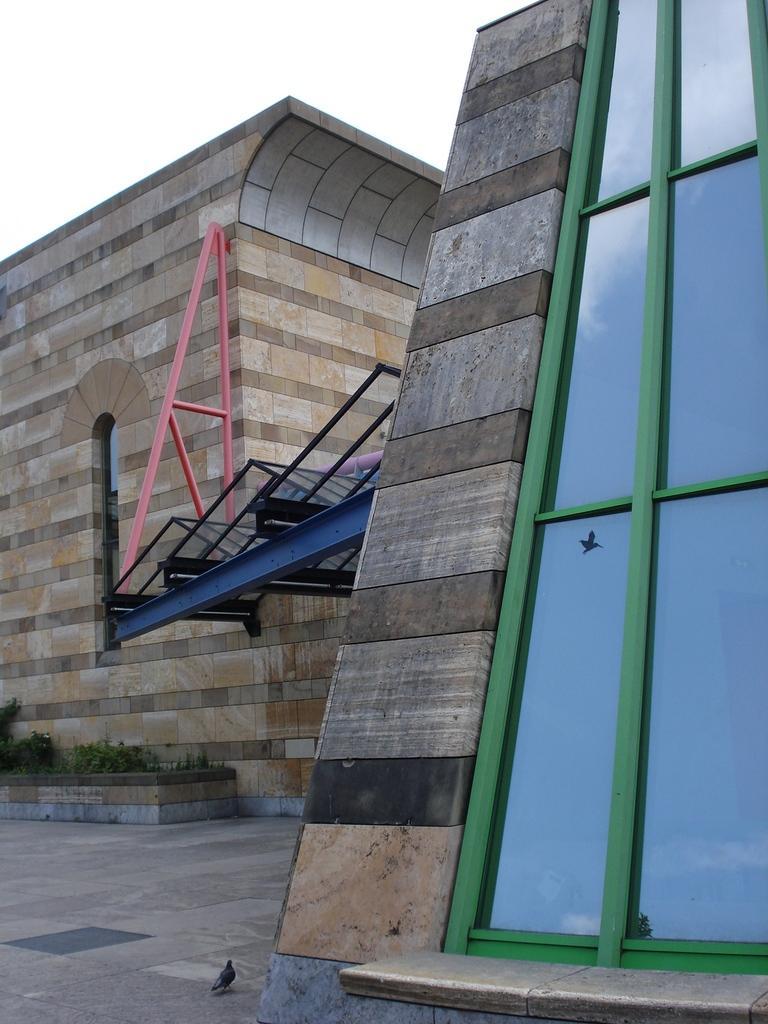Could you give a brief overview of what you see in this image? In the center of the image a building is present. At the bottom of the image we can see a pigeon, some plants and glass are present. At the top of the image sky is there. 